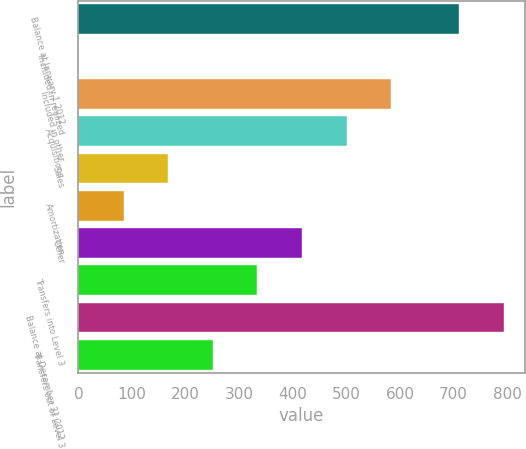Convert chart. <chart><loc_0><loc_0><loc_500><loc_500><bar_chart><fcel>Balance at January 1 2012<fcel>Included in realized<fcel>Included in other<fcel>Acquisitions<fcel>Sales<fcel>Amortization<fcel>Other<fcel>Transfers into Level 3<fcel>Balance at December 31 2012<fcel>Transfers out of Level 3<nl><fcel>710<fcel>1.02<fcel>583.42<fcel>500.22<fcel>167.42<fcel>84.22<fcel>417.02<fcel>333.82<fcel>793.2<fcel>250.62<nl></chart> 